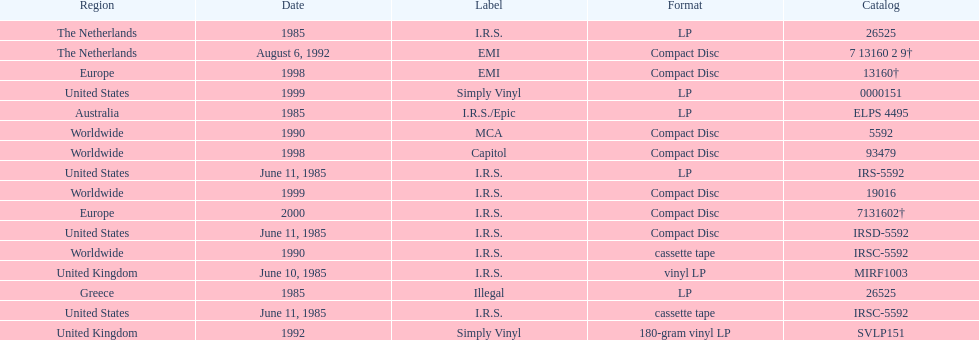What is the greatest consecutive amount of releases in lp format? 3. 